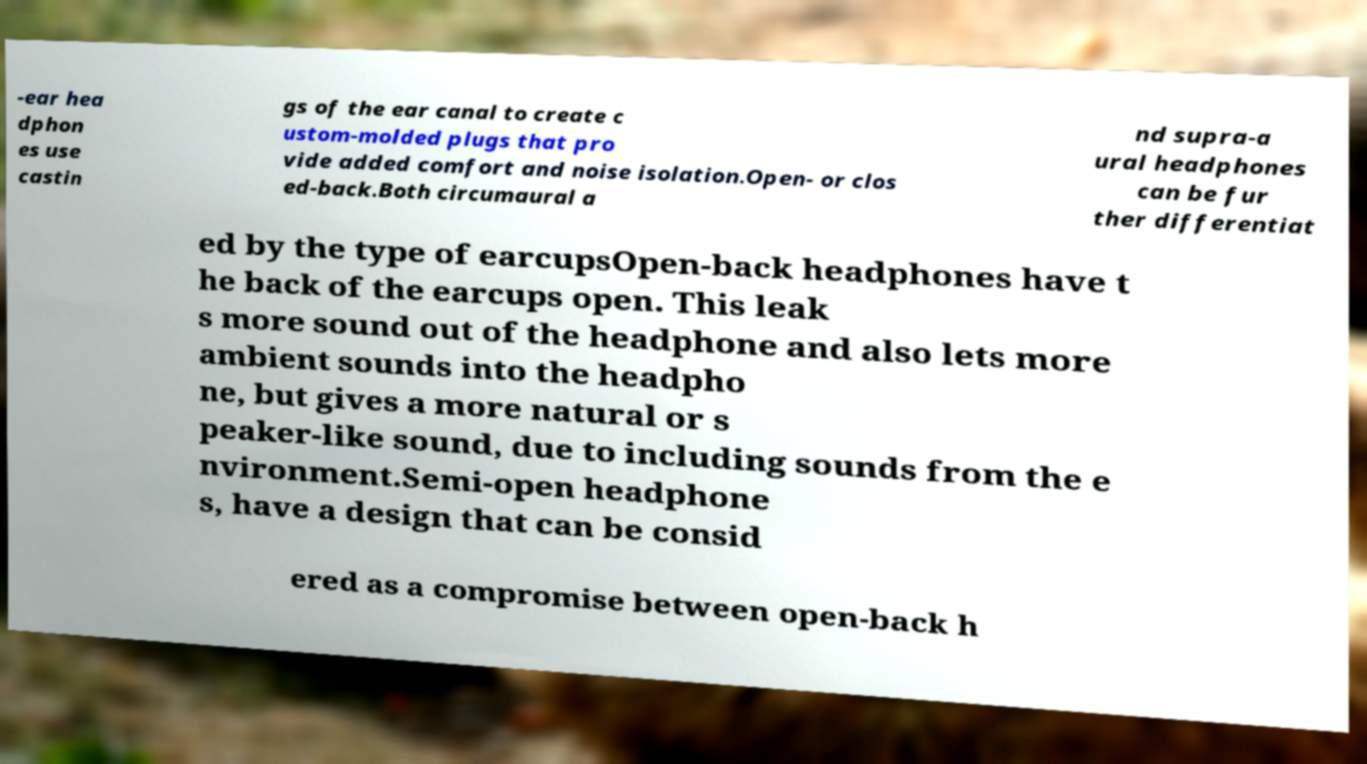I need the written content from this picture converted into text. Can you do that? -ear hea dphon es use castin gs of the ear canal to create c ustom-molded plugs that pro vide added comfort and noise isolation.Open- or clos ed-back.Both circumaural a nd supra-a ural headphones can be fur ther differentiat ed by the type of earcupsOpen-back headphones have t he back of the earcups open. This leak s more sound out of the headphone and also lets more ambient sounds into the headpho ne, but gives a more natural or s peaker-like sound, due to including sounds from the e nvironment.Semi-open headphone s, have a design that can be consid ered as a compromise between open-back h 